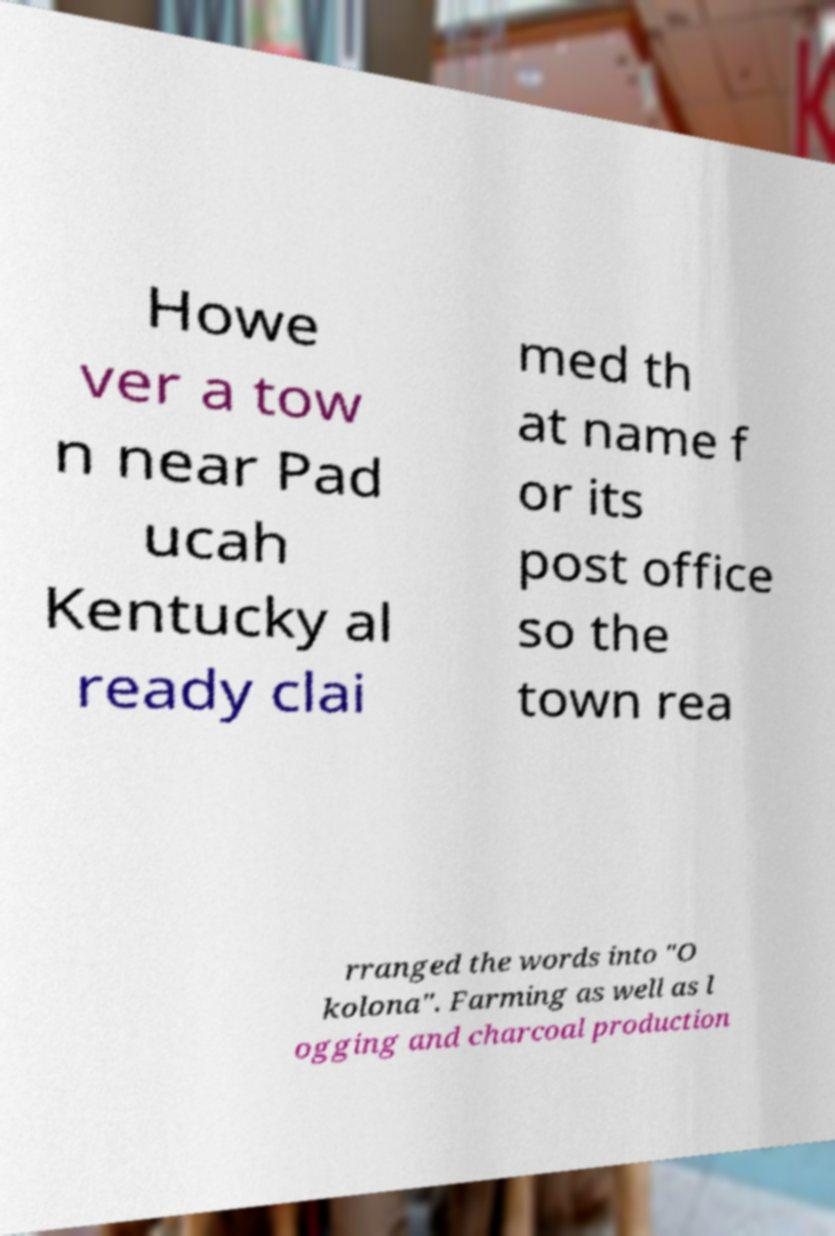Could you extract and type out the text from this image? Howe ver a tow n near Pad ucah Kentucky al ready clai med th at name f or its post office so the town rea rranged the words into "O kolona". Farming as well as l ogging and charcoal production 